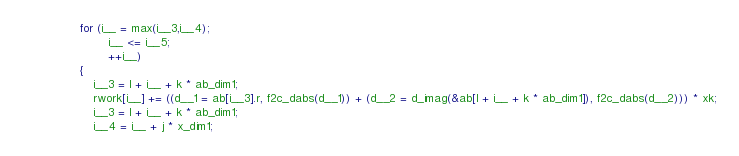<code> <loc_0><loc_0><loc_500><loc_500><_C_>                for (i__ = max(i__3,i__4);
                        i__ <= i__5;
                        ++i__)
                {
                    i__3 = l + i__ + k * ab_dim1;
                    rwork[i__] += ((d__1 = ab[i__3].r, f2c_dabs(d__1)) + (d__2 = d_imag(&ab[l + i__ + k * ab_dim1]), f2c_dabs(d__2))) * xk;
                    i__3 = l + i__ + k * ab_dim1;
                    i__4 = i__ + j * x_dim1;</code> 